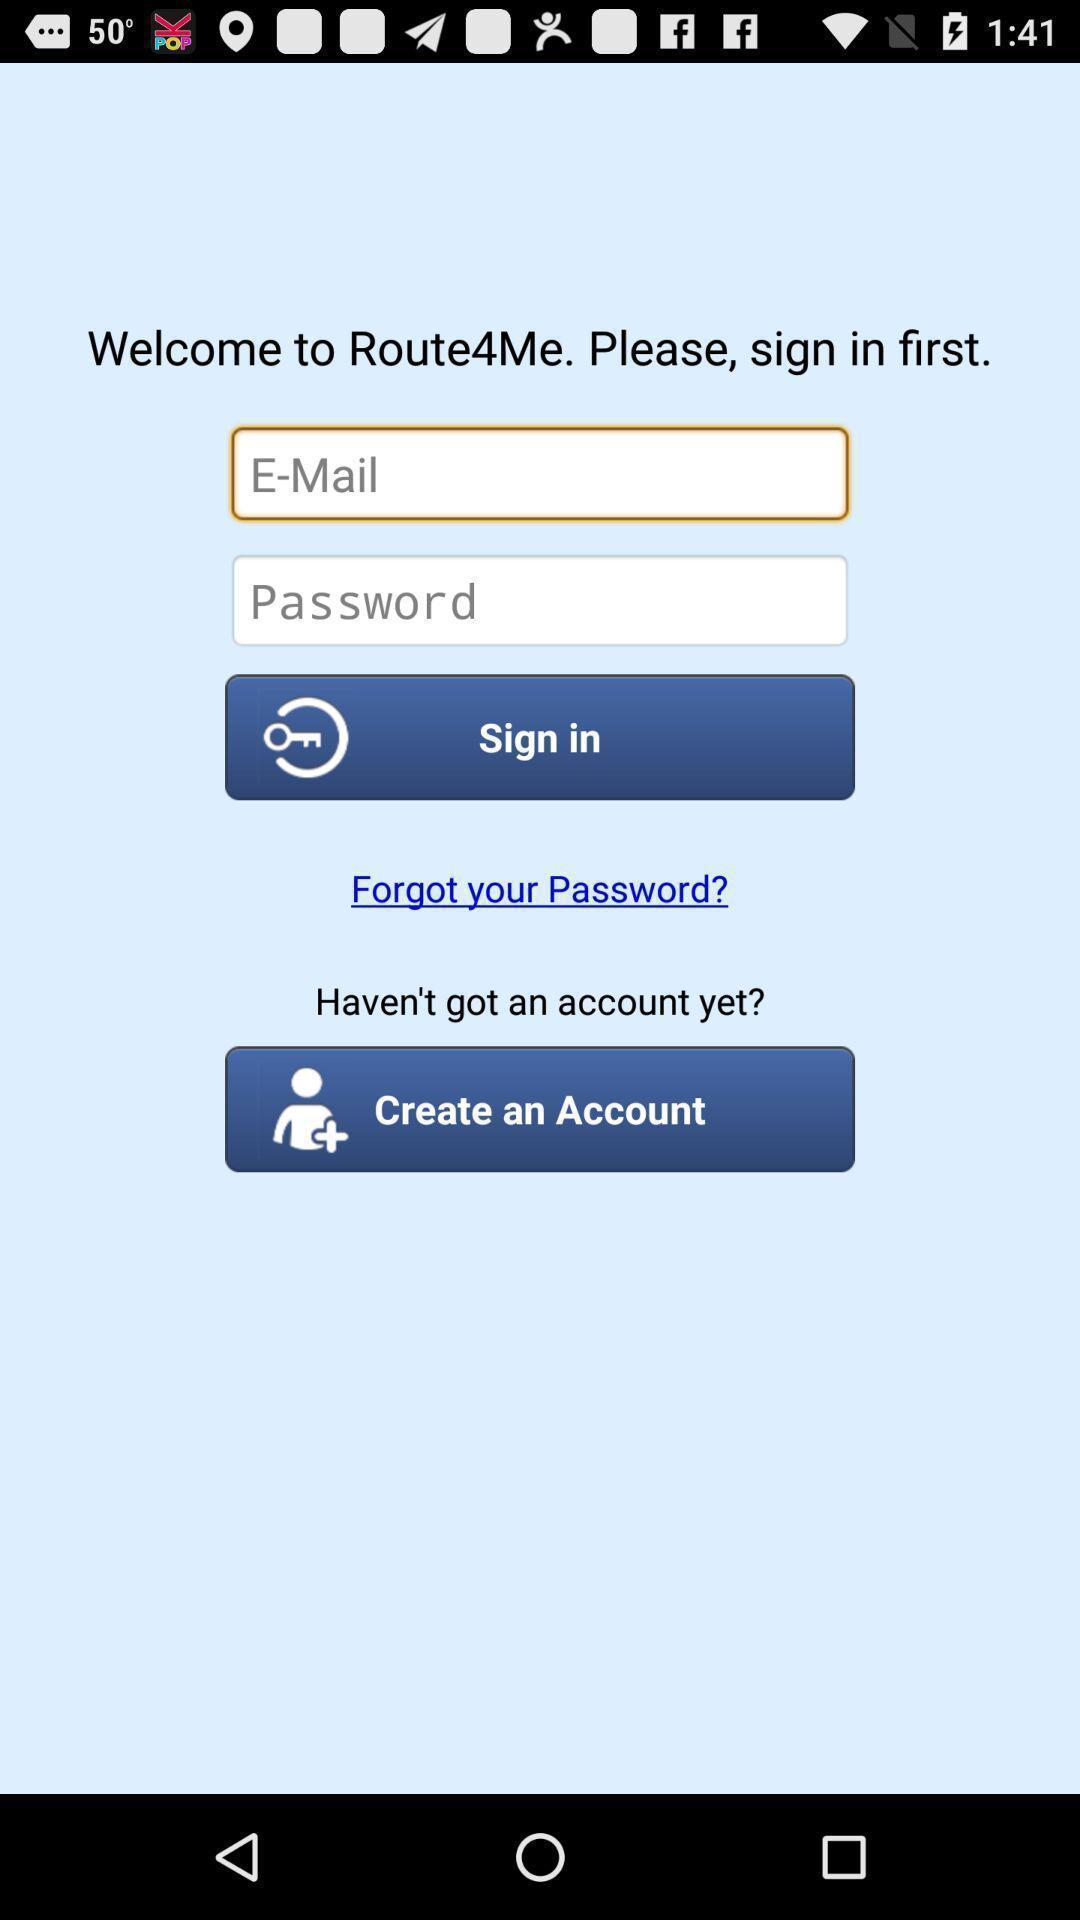Summarize the main components in this picture. Sign up page. 